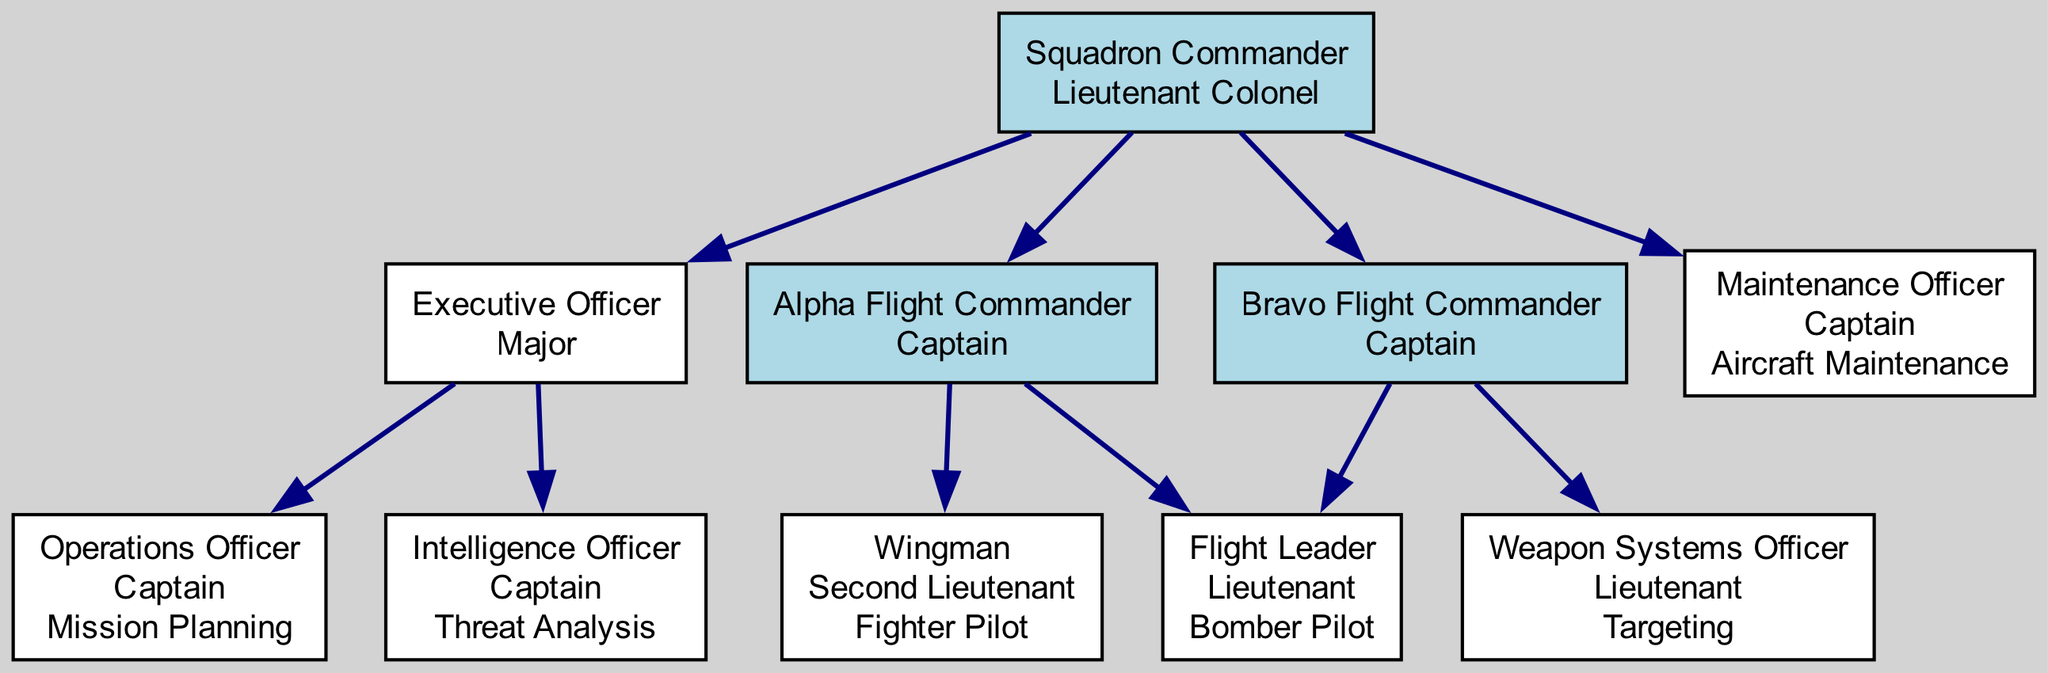What is the rank of the Squadron Commander? The rank of the Squadron Commander is stated in the diagram as "Lieutenant Colonel."
Answer: Lieutenant Colonel How many children does the Executive Officer have? The Executive Officer has two children: the Operations Officer and the Intelligence Officer, as shown in the diagram.
Answer: 2 What is the specialty of the Intelligence Officer? The specialty of the Intelligence Officer is written in the diagram as "Threat Analysis."
Answer: Threat Analysis Who is the Flight Leader under Alpha Flight Commander? The diagram identifies the Flight Leader under the Alpha Flight Commander as a "Lieutenant."
Answer: Lieutenant Which rank has the most officers at this level? By analyzing the diagram, both the Alpha and Bravo Flight Commanders have the same number of officers (two) below them, but the highest rank with officers is "Captain," held by both Flight Commanders and the Maintenance Officer.
Answer: Captain What specialty is associated with the Maintenance Officer? The diagram specifies the specialty of the Maintenance Officer as "Aircraft Maintenance."
Answer: Aircraft Maintenance How many total ranks are depicted in the diagram? The ranks outlined in the diagram are: Lieutenant Colonel, Major, Captain, Lieutenant, and Second Lieutenant, amounting to five distinct ranks.
Answer: 5 What relationship does the Maintenance Officer have to the Squadron Commander? The Maintenance Officer is a direct subordinate to the Squadron Commander, confirming a hierarchical structure in the diagram.
Answer: Subordinate Which flight has the Bomber Pilot as a Flight Leader? The diagram shows that the Bravo Flight has the Bomber Pilot as a Flight Leader, indicated clearly in its hierarchy.
Answer: Bravo Flight 